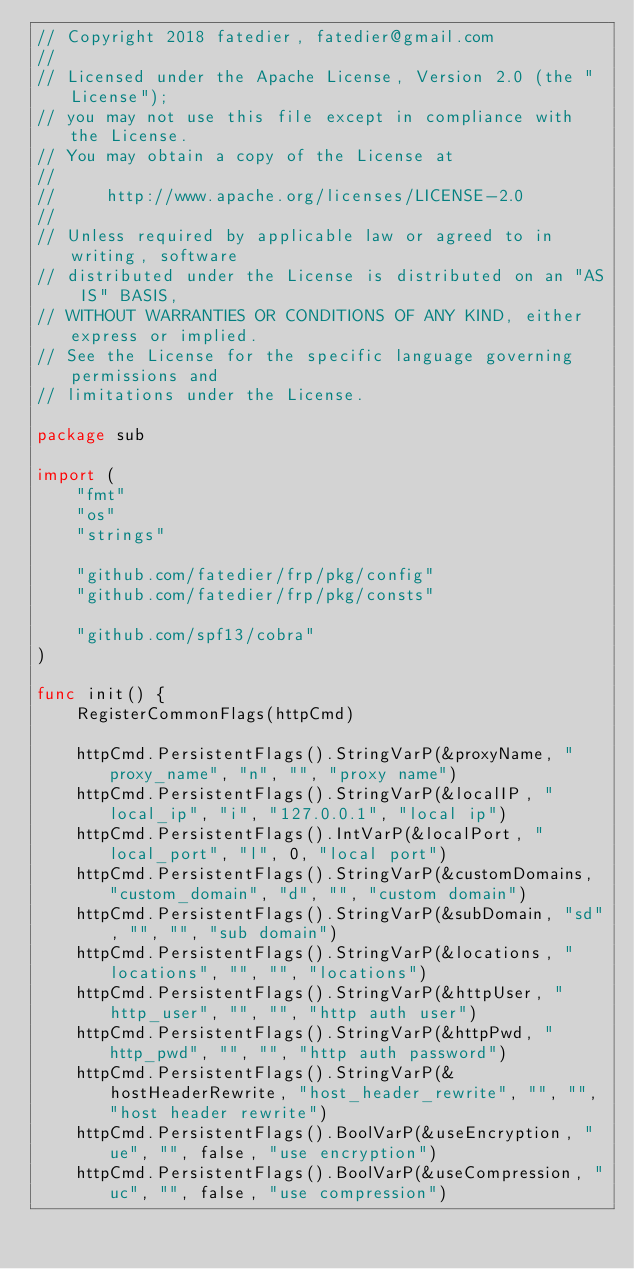<code> <loc_0><loc_0><loc_500><loc_500><_Go_>// Copyright 2018 fatedier, fatedier@gmail.com
//
// Licensed under the Apache License, Version 2.0 (the "License");
// you may not use this file except in compliance with the License.
// You may obtain a copy of the License at
//
//     http://www.apache.org/licenses/LICENSE-2.0
//
// Unless required by applicable law or agreed to in writing, software
// distributed under the License is distributed on an "AS IS" BASIS,
// WITHOUT WARRANTIES OR CONDITIONS OF ANY KIND, either express or implied.
// See the License for the specific language governing permissions and
// limitations under the License.

package sub

import (
	"fmt"
	"os"
	"strings"

	"github.com/fatedier/frp/pkg/config"
	"github.com/fatedier/frp/pkg/consts"

	"github.com/spf13/cobra"
)

func init() {
	RegisterCommonFlags(httpCmd)

	httpCmd.PersistentFlags().StringVarP(&proxyName, "proxy_name", "n", "", "proxy name")
	httpCmd.PersistentFlags().StringVarP(&localIP, "local_ip", "i", "127.0.0.1", "local ip")
	httpCmd.PersistentFlags().IntVarP(&localPort, "local_port", "l", 0, "local port")
	httpCmd.PersistentFlags().StringVarP(&customDomains, "custom_domain", "d", "", "custom domain")
	httpCmd.PersistentFlags().StringVarP(&subDomain, "sd", "", "", "sub domain")
	httpCmd.PersistentFlags().StringVarP(&locations, "locations", "", "", "locations")
	httpCmd.PersistentFlags().StringVarP(&httpUser, "http_user", "", "", "http auth user")
	httpCmd.PersistentFlags().StringVarP(&httpPwd, "http_pwd", "", "", "http auth password")
	httpCmd.PersistentFlags().StringVarP(&hostHeaderRewrite, "host_header_rewrite", "", "", "host header rewrite")
	httpCmd.PersistentFlags().BoolVarP(&useEncryption, "ue", "", false, "use encryption")
	httpCmd.PersistentFlags().BoolVarP(&useCompression, "uc", "", false, "use compression")
</code> 